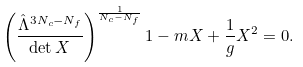Convert formula to latex. <formula><loc_0><loc_0><loc_500><loc_500>\left ( \frac { \hat { \Lambda } ^ { 3 N _ { c } - N _ { f } } } { \det X } \right ) ^ { \frac { 1 } { N _ { c } - N _ { f } } } 1 - m X + \frac { 1 } { g } X ^ { 2 } = 0 .</formula> 